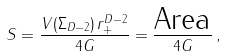Convert formula to latex. <formula><loc_0><loc_0><loc_500><loc_500>S = \frac { V ( \Sigma _ { D - 2 } ) \, r _ { + } ^ { D - 2 } } { 4 G } = \frac { \text {Area} } { 4 G } \, ,</formula> 